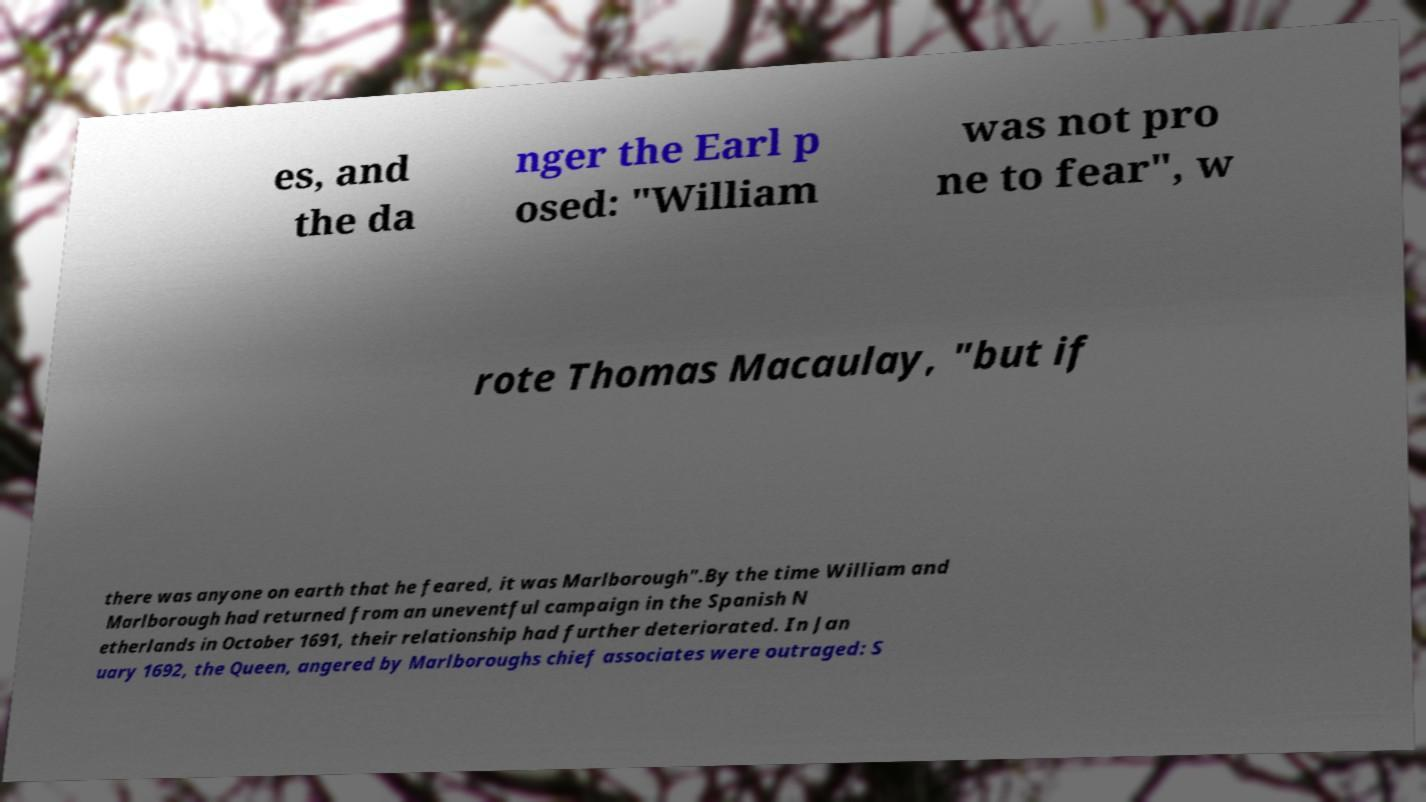Can you read and provide the text displayed in the image?This photo seems to have some interesting text. Can you extract and type it out for me? es, and the da nger the Earl p osed: "William was not pro ne to fear", w rote Thomas Macaulay, "but if there was anyone on earth that he feared, it was Marlborough".By the time William and Marlborough had returned from an uneventful campaign in the Spanish N etherlands in October 1691, their relationship had further deteriorated. In Jan uary 1692, the Queen, angered by Marlboroughs chief associates were outraged: S 